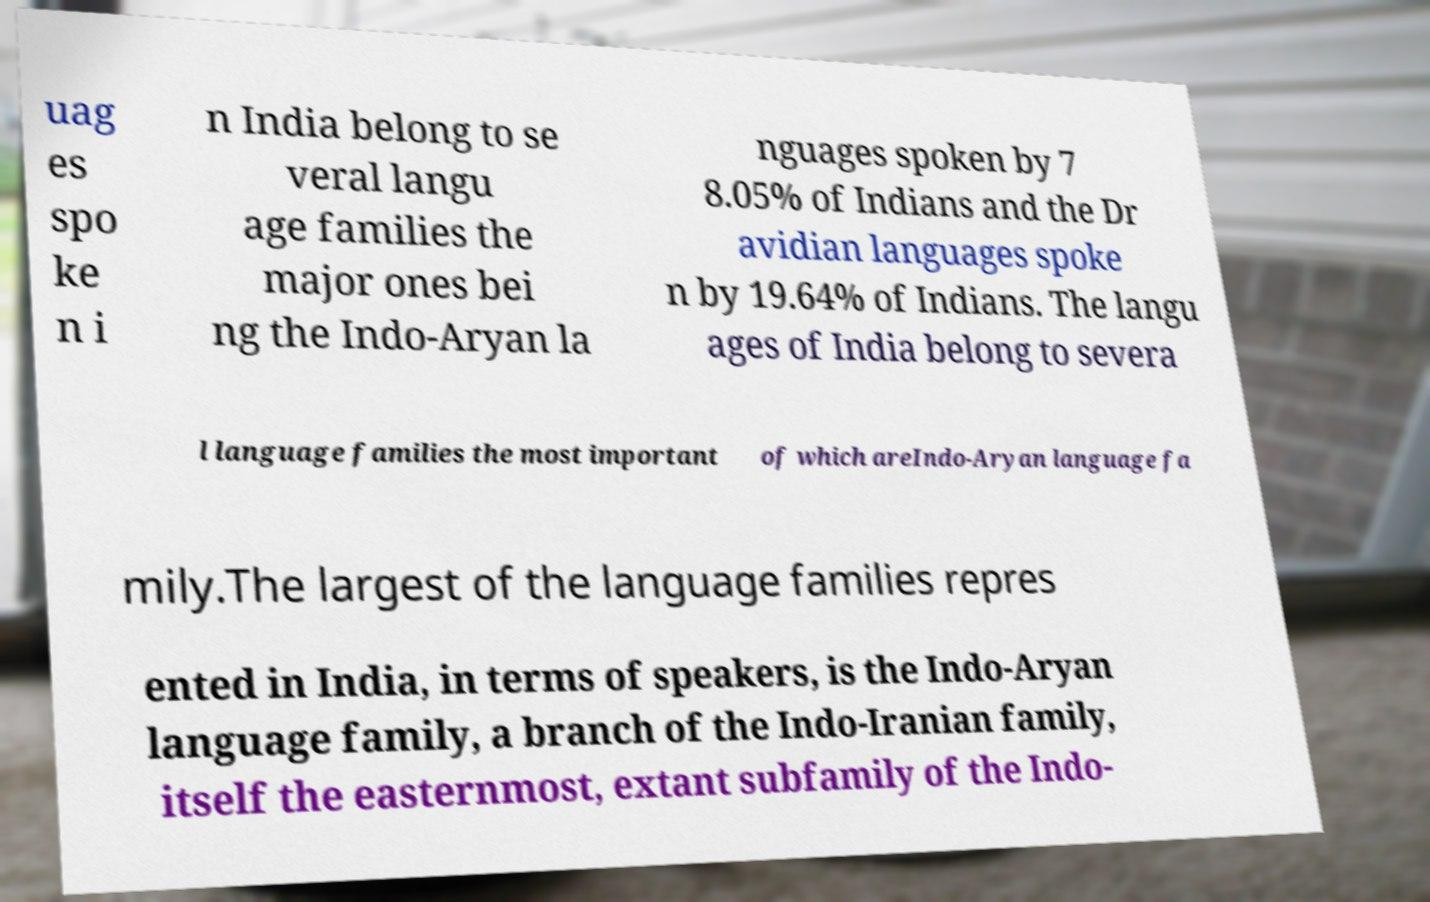Please read and relay the text visible in this image. What does it say? uag es spo ke n i n India belong to se veral langu age families the major ones bei ng the Indo-Aryan la nguages spoken by 7 8.05% of Indians and the Dr avidian languages spoke n by 19.64% of Indians. The langu ages of India belong to severa l language families the most important of which areIndo-Aryan language fa mily.The largest of the language families repres ented in India, in terms of speakers, is the Indo-Aryan language family, a branch of the Indo-Iranian family, itself the easternmost, extant subfamily of the Indo- 